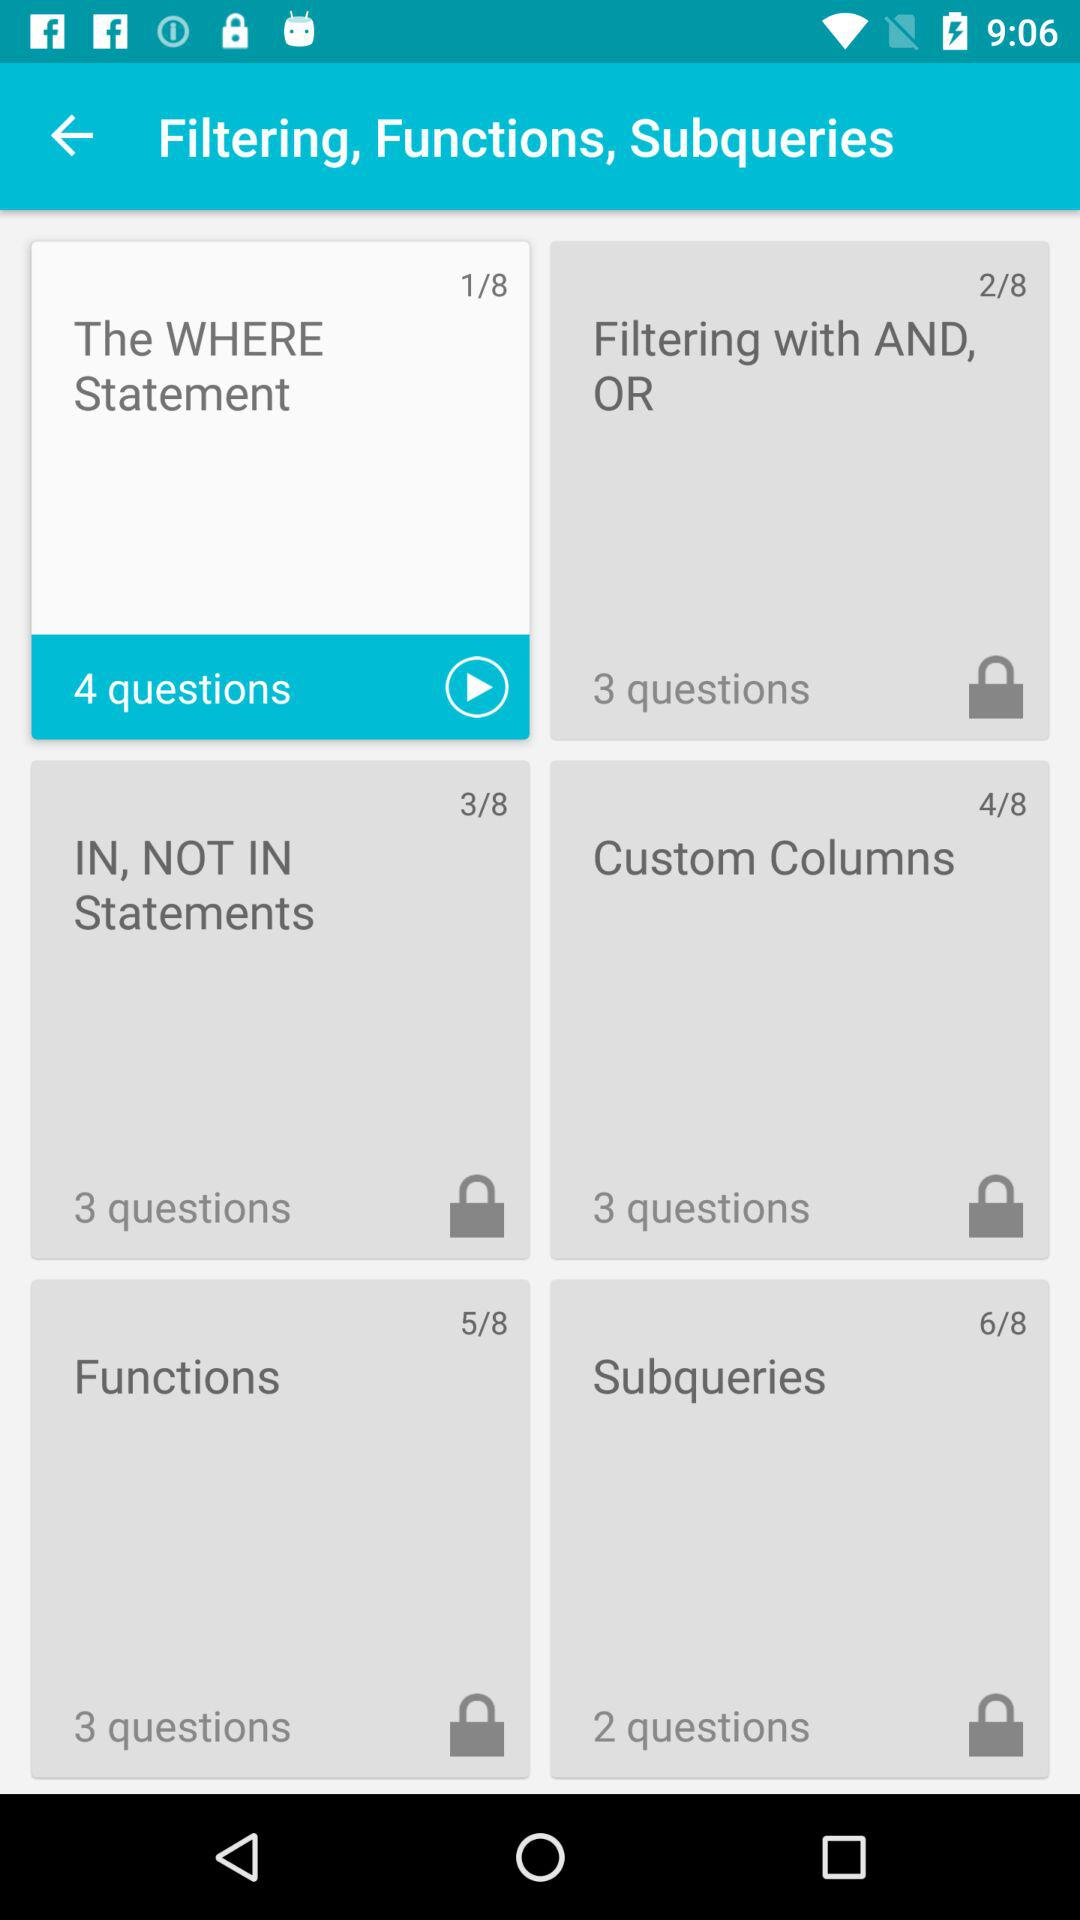How many questions are present in "The WHERE Statement"? There are 4 questions present in "The WHERE Statement". 